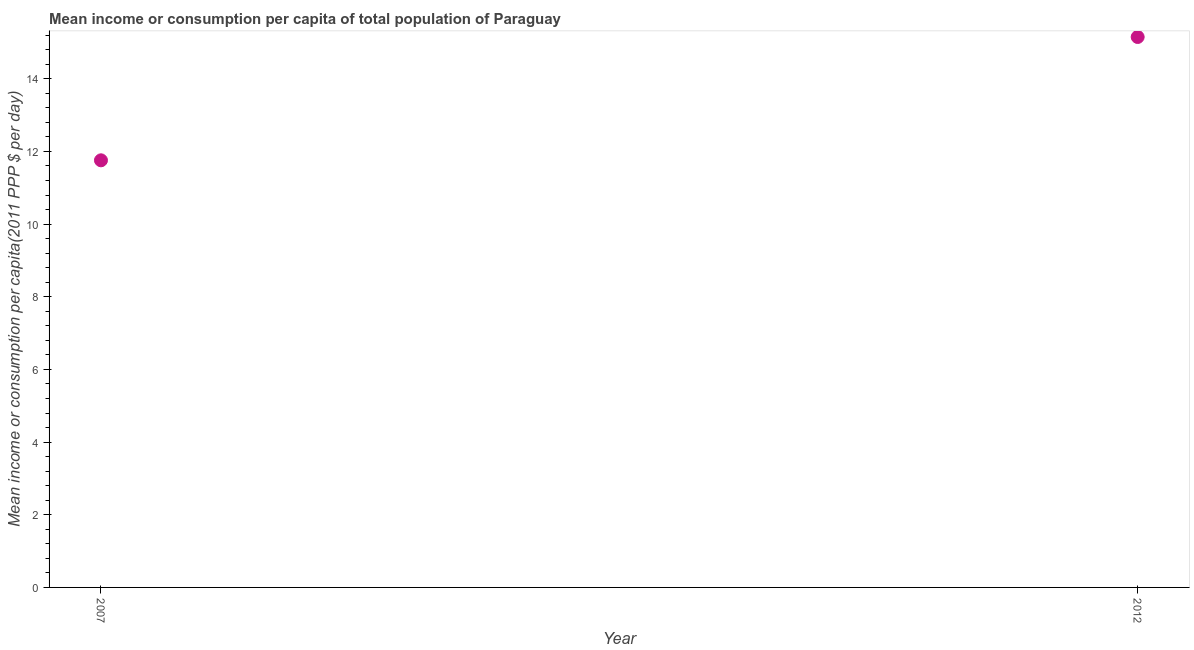What is the mean income or consumption in 2012?
Your response must be concise. 15.15. Across all years, what is the maximum mean income or consumption?
Your response must be concise. 15.15. Across all years, what is the minimum mean income or consumption?
Your response must be concise. 11.75. In which year was the mean income or consumption minimum?
Your answer should be compact. 2007. What is the sum of the mean income or consumption?
Your response must be concise. 26.9. What is the difference between the mean income or consumption in 2007 and 2012?
Keep it short and to the point. -3.39. What is the average mean income or consumption per year?
Make the answer very short. 13.45. What is the median mean income or consumption?
Provide a succinct answer. 13.45. Do a majority of the years between 2007 and 2012 (inclusive) have mean income or consumption greater than 7.6 $?
Keep it short and to the point. Yes. What is the ratio of the mean income or consumption in 2007 to that in 2012?
Give a very brief answer. 0.78. In how many years, is the mean income or consumption greater than the average mean income or consumption taken over all years?
Your response must be concise. 1. Does the mean income or consumption monotonically increase over the years?
Provide a succinct answer. Yes. How many dotlines are there?
Provide a succinct answer. 1. How many years are there in the graph?
Offer a terse response. 2. Are the values on the major ticks of Y-axis written in scientific E-notation?
Offer a very short reply. No. What is the title of the graph?
Ensure brevity in your answer.  Mean income or consumption per capita of total population of Paraguay. What is the label or title of the Y-axis?
Provide a short and direct response. Mean income or consumption per capita(2011 PPP $ per day). What is the Mean income or consumption per capita(2011 PPP $ per day) in 2007?
Your answer should be compact. 11.75. What is the Mean income or consumption per capita(2011 PPP $ per day) in 2012?
Provide a succinct answer. 15.15. What is the difference between the Mean income or consumption per capita(2011 PPP $ per day) in 2007 and 2012?
Provide a succinct answer. -3.39. What is the ratio of the Mean income or consumption per capita(2011 PPP $ per day) in 2007 to that in 2012?
Your answer should be compact. 0.78. 